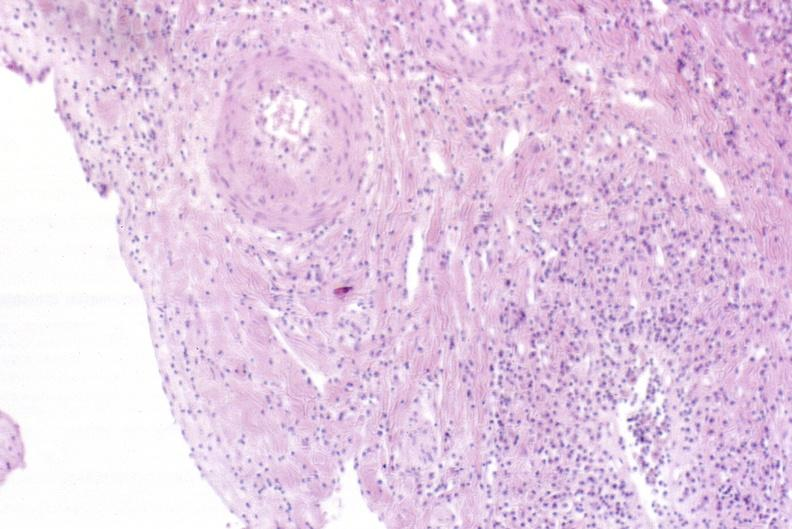does arcus senilis show severe acute rejection?
Answer the question using a single word or phrase. No 